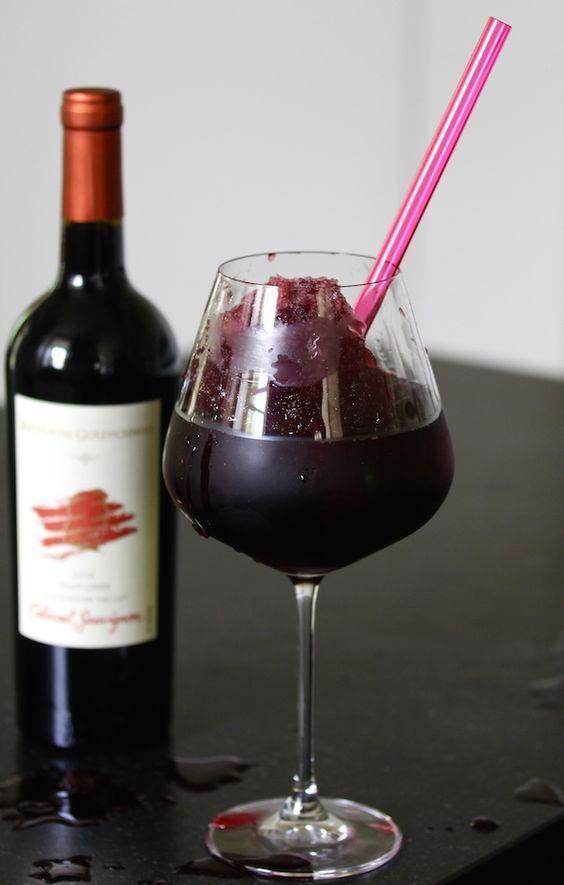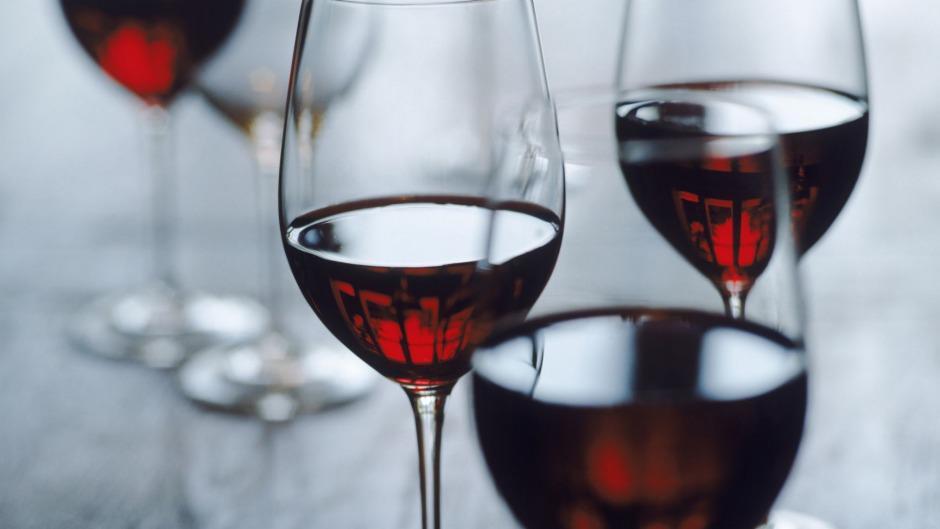The first image is the image on the left, the second image is the image on the right. Given the left and right images, does the statement "there is a bottle of wine in the iamge on the left" hold true? Answer yes or no. Yes. The first image is the image on the left, the second image is the image on the right. For the images shown, is this caption "An image shows only several partly filled wine glasses." true? Answer yes or no. Yes. 